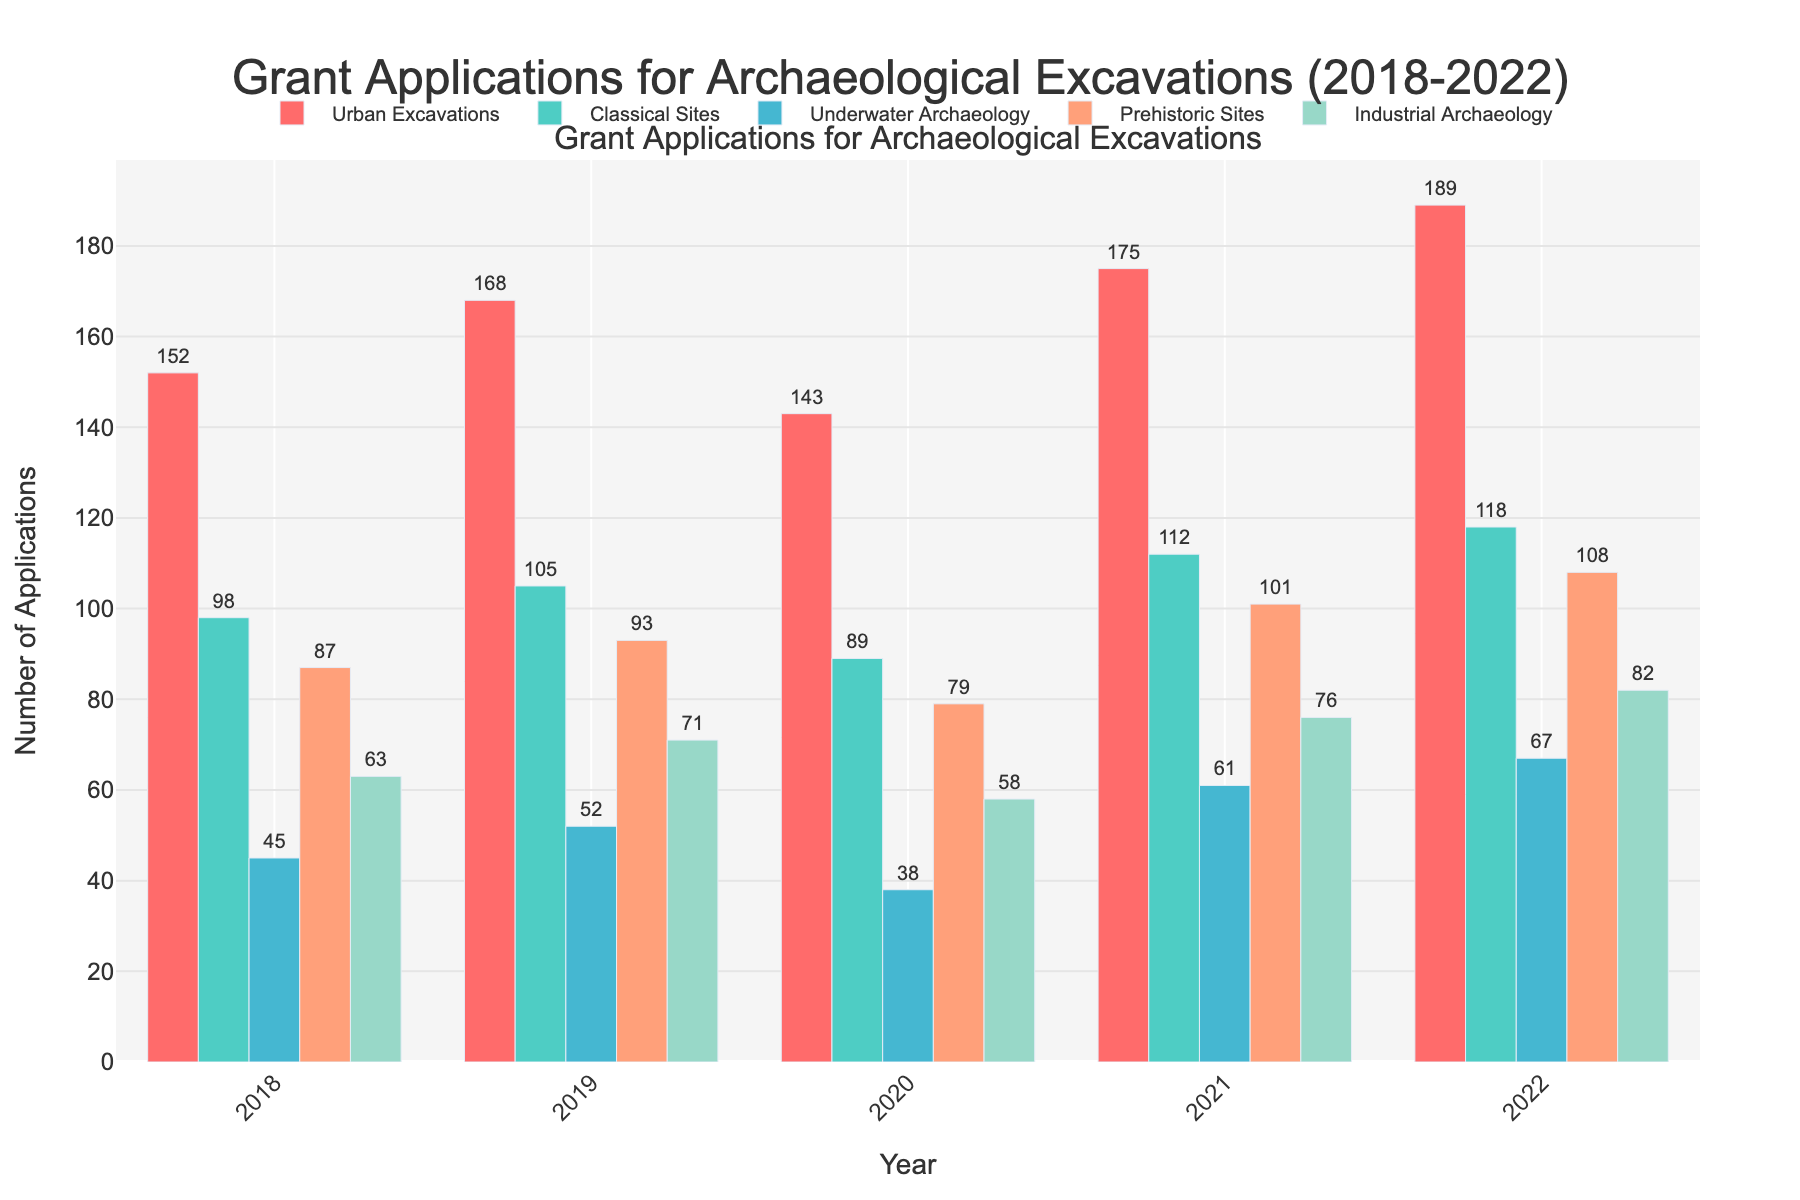Which type of excavation had the highest number of grant applications in 2022? Look at the bars for 2022 and identify the tallest bar among the categories. Urban Excavations has the tallest bar.
Answer: Urban Excavations How did the number of applications for Industrial Archaeology change from 2018 to 2022? Compare the height of the bars for Industrial Archaeology in 2018 and 2022. In 2018, it is 63, and in 2022, it is 82. The number increased.
Answer: Increased What is the average number of grant applications received annually for Prehistoric Sites over the five years? Add up the values for Prehistoric Sites from 2018 to 2022 and divide by 5: (87 + 93 + 79 + 101 + 108) / 5. The sum is 468, and the average is 468 / 5 = 93.6
Answer: 93.6 Which year saw the highest total number of grant applications across all categories? Sum the bars for each year and identify the highest sum. 2022: 189 + 118 + 67 + 108 + 82 = 564; 2021: 175 + 112 + 61 + 101 + 76 = 525; 2020: 143 + 89 + 38 + 79 + 58 = 407; 2019: 168 + 105 + 52 + 93 + 71 = 489; 2018: 152 + 98 + 45 + 87 + 63 = 445
Answer: 2022 Which type of excavation received consistently increasing applications over the five years? Check the bars of each category for a consistent upward trend from 2018 to 2022. Urban Excavations, Classical Sites, Underwater Archaeology, Prehistoric Sites, and Industrial Archaeology all show an increase in applications each year.
Answer: All categories How many more applications were there for Underwater Archaeology in 2022 compared to 2020? Subtract the number of applications for Underwater Archaeology in 2020 from 2022: 67 - 38 = 29.
Answer: 29 Which year had the smallest increase in applications from the previous year for Classical Sites? Calculate the differences for Classical Sites: 2019-2018: 105 - 98 = 7; 2020-2019: 89 - 105 = -16; 2021-2020: 112 - 89 = 23; 2022-2021: 118 - 112 = 6. The smallest increase is from 2021 to 2022 with 6.
Answer: 2022 What is the difference between the highest and lowest number of applications received for Urban Excavations over the five years? Identify the highest and lowest values for Urban Excavations and subtract them: Highest is 189 (2022), lowest is 143 (2020). Difference: 189 - 143 = 46.
Answer: 46 In which year did Prehistoric Sites see the largest increase in applications as compared to the previous year? Calculate the yearly increases for Prehistoric Sites: 2019-2018: 93 - 87 = 6, 2020-2019: 79 - 93 = -14, 2021-2020: 101 - 79 = 22, 2022-2021: 108 - 101 = 7. The largest increase is 22 from 2020 to 2021.
Answer: 2021 